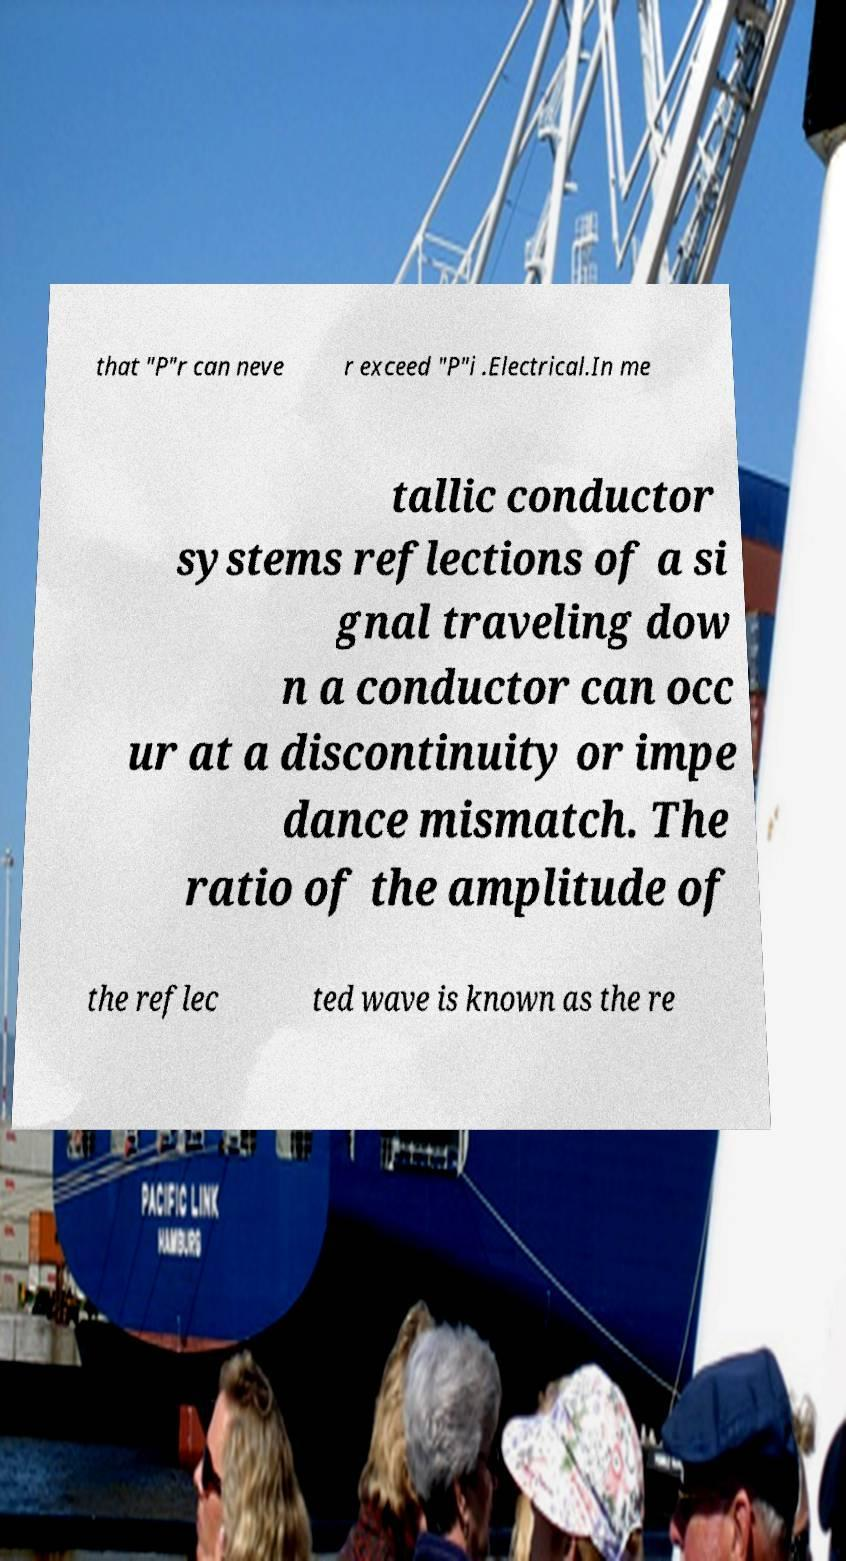Could you assist in decoding the text presented in this image and type it out clearly? that "P"r can neve r exceed "P"i .Electrical.In me tallic conductor systems reflections of a si gnal traveling dow n a conductor can occ ur at a discontinuity or impe dance mismatch. The ratio of the amplitude of the reflec ted wave is known as the re 